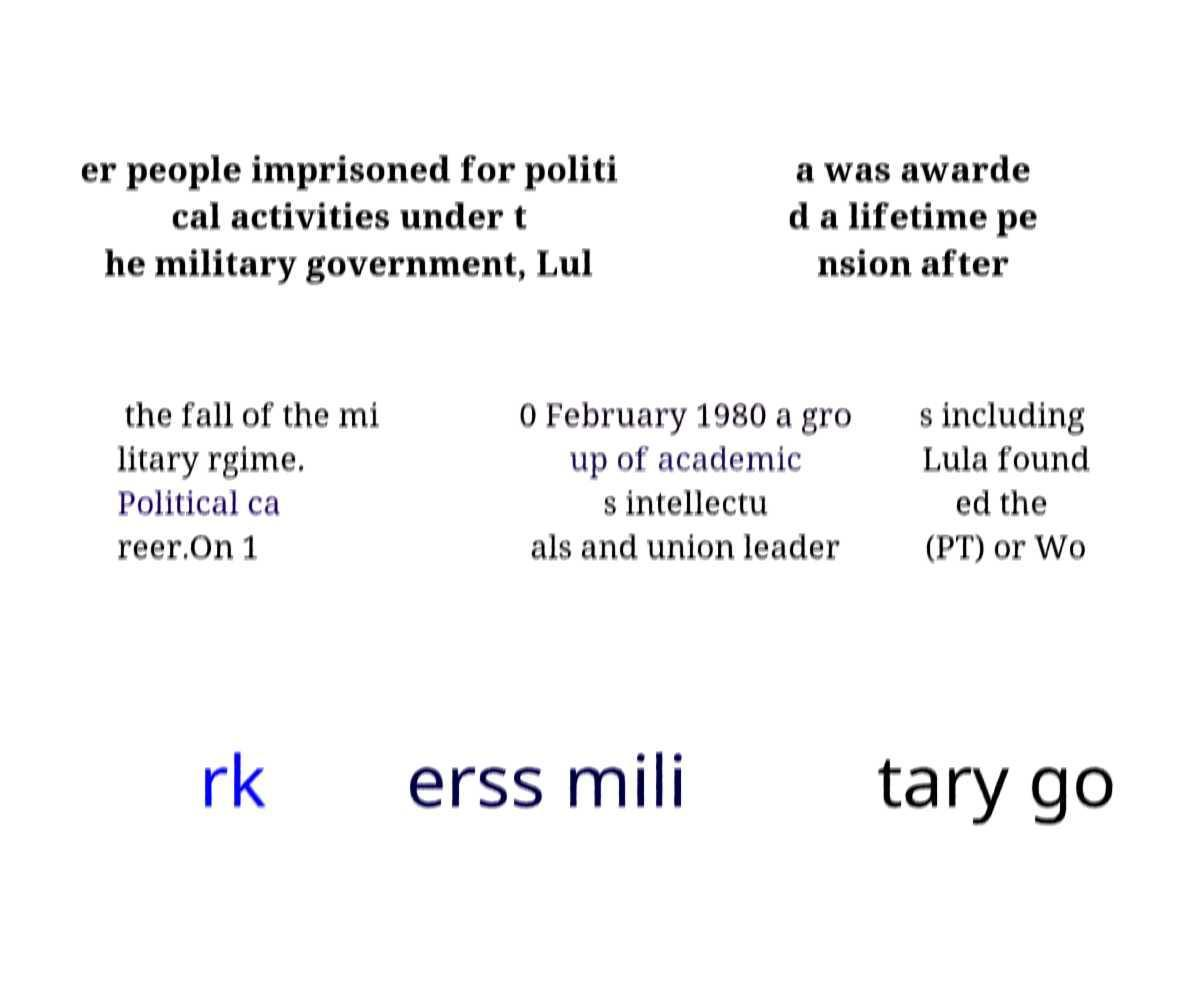Can you accurately transcribe the text from the provided image for me? er people imprisoned for politi cal activities under t he military government, Lul a was awarde d a lifetime pe nsion after the fall of the mi litary rgime. Political ca reer.On 1 0 February 1980 a gro up of academic s intellectu als and union leader s including Lula found ed the (PT) or Wo rk erss mili tary go 